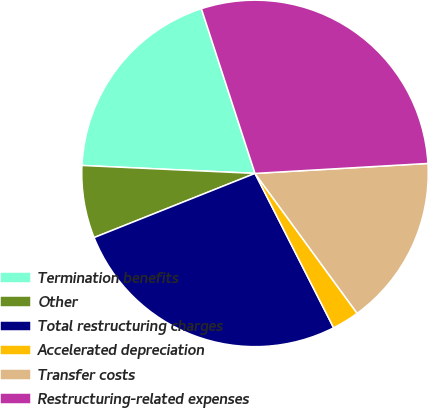Convert chart to OTSL. <chart><loc_0><loc_0><loc_500><loc_500><pie_chart><fcel>Termination benefits<fcel>Other<fcel>Total restructuring charges<fcel>Accelerated depreciation<fcel>Transfer costs<fcel>Restructuring-related expenses<nl><fcel>19.26%<fcel>6.77%<fcel>26.46%<fcel>2.54%<fcel>15.88%<fcel>29.09%<nl></chart> 